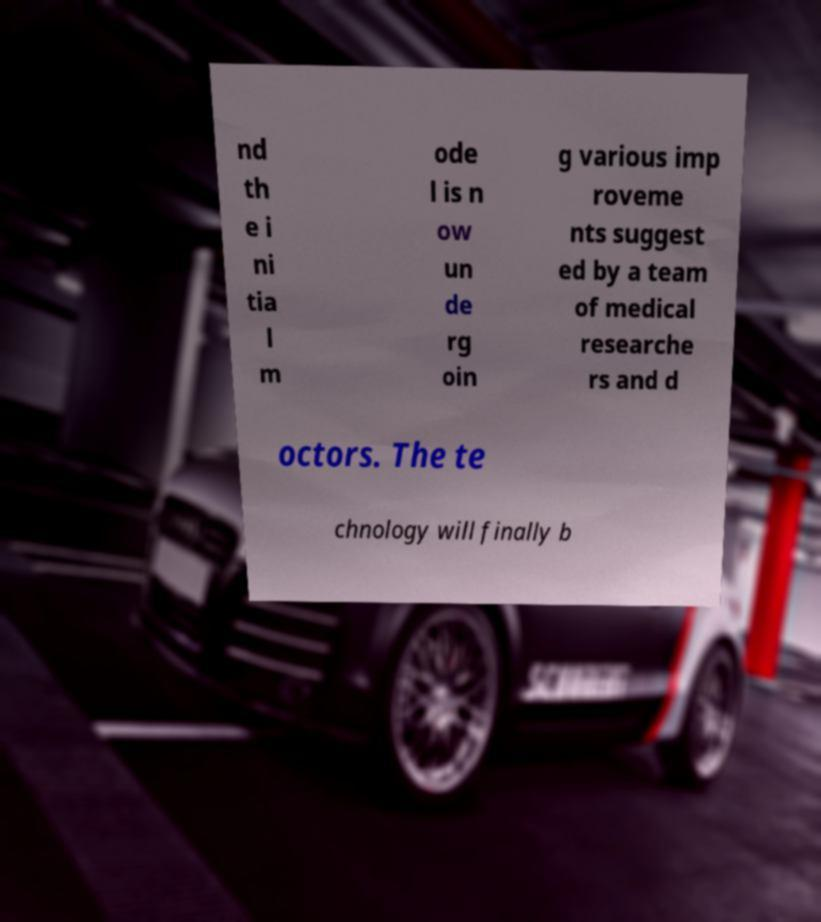Could you assist in decoding the text presented in this image and type it out clearly? nd th e i ni tia l m ode l is n ow un de rg oin g various imp roveme nts suggest ed by a team of medical researche rs and d octors. The te chnology will finally b 